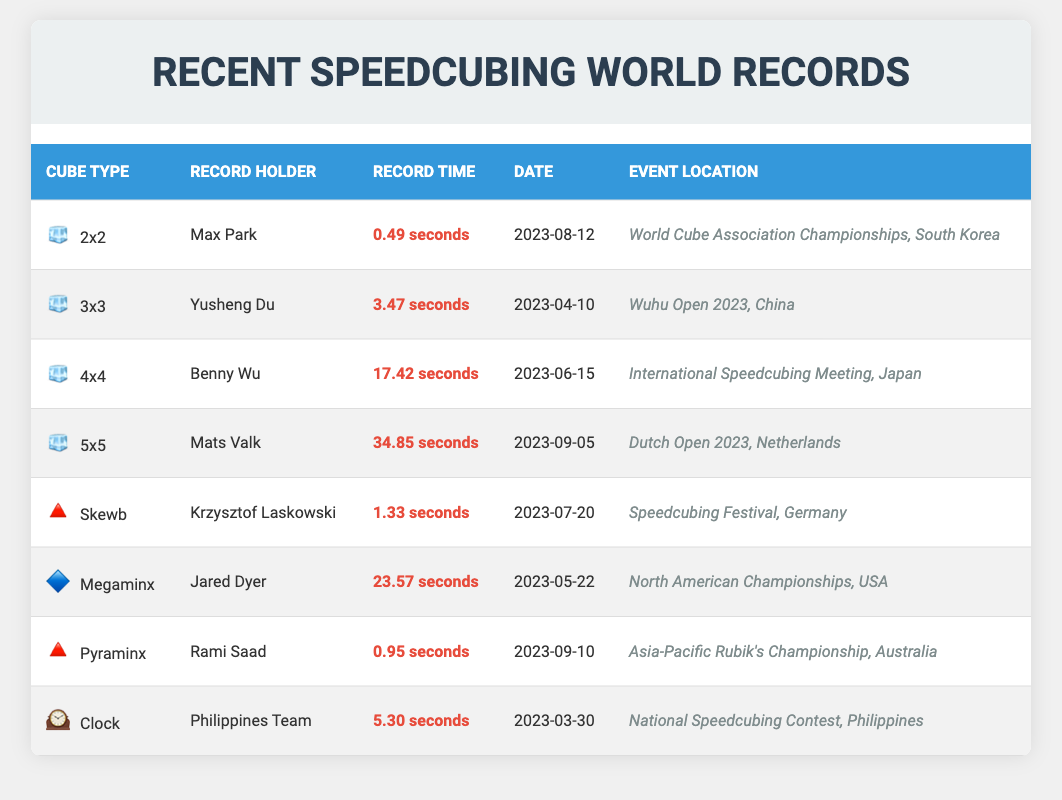What is the fastest record time for a 2x2 cube? The record time for the 2x2 cube is listed in the table as 0.49 seconds, held by Max Park.
Answer: 0.49 seconds Who set the world record for the 3x3 cube? The record holder for the 3x3 cube is identified as Yusheng Du in the table.
Answer: Yusheng Du Which cube type has the longest recorded time? By comparing all the recorded times in the table, the 5x5 cube with a record time of 34.85 seconds is the longest.
Answer: 5x5 cube Is there a record holder for the Skewb cube type? Yes, the table shows that Krzysztof Laskowski holds the record for the Skewb cube.
Answer: Yes Which cube type has a record time under 1 second? The table shows that both the 2x2 cube (0.49 seconds) and the Pyraminx (0.95 seconds) have record times under 1 second.
Answer: 2x2 and Pyraminx What is the average record time for cubes with records under 5 seconds? The cubes with records under 5 seconds are 2x2 (0.49), Pyraminx (0.95), and Clock (5.30). Their sum is 0.49 + 0.95 + 5.30 = 6.74. There are 3 records, so the average is 6.74 / 3 = 2.25 seconds.
Answer: 2.25 seconds Which event had the fastest speedcubing record overall? By checking the record times, the 2x2 cube with a record time of 0.49 seconds is the fastest overall.
Answer: 0.49 seconds When was the most recent record set, and for which cube type? The most recent record in the table is for the 5x5 cube, set on 2023-09-05 by Mats Valk.
Answer: 5x5 cube on 2023-09-05 How many different cube types have records set in 2023? The table lists records for 8 different cube types, all of which were set in 2023.
Answer: 8 cube types Compare the median record times for the 4x4 and Megaminx cubes. The 4x4 record is 17.42 seconds, and the Megaminx record is 23.57 seconds. Since there are two values, the median is the average of these two, which is (17.42 + 23.57) / 2 = 20.495 seconds.
Answer: 20.495 seconds 